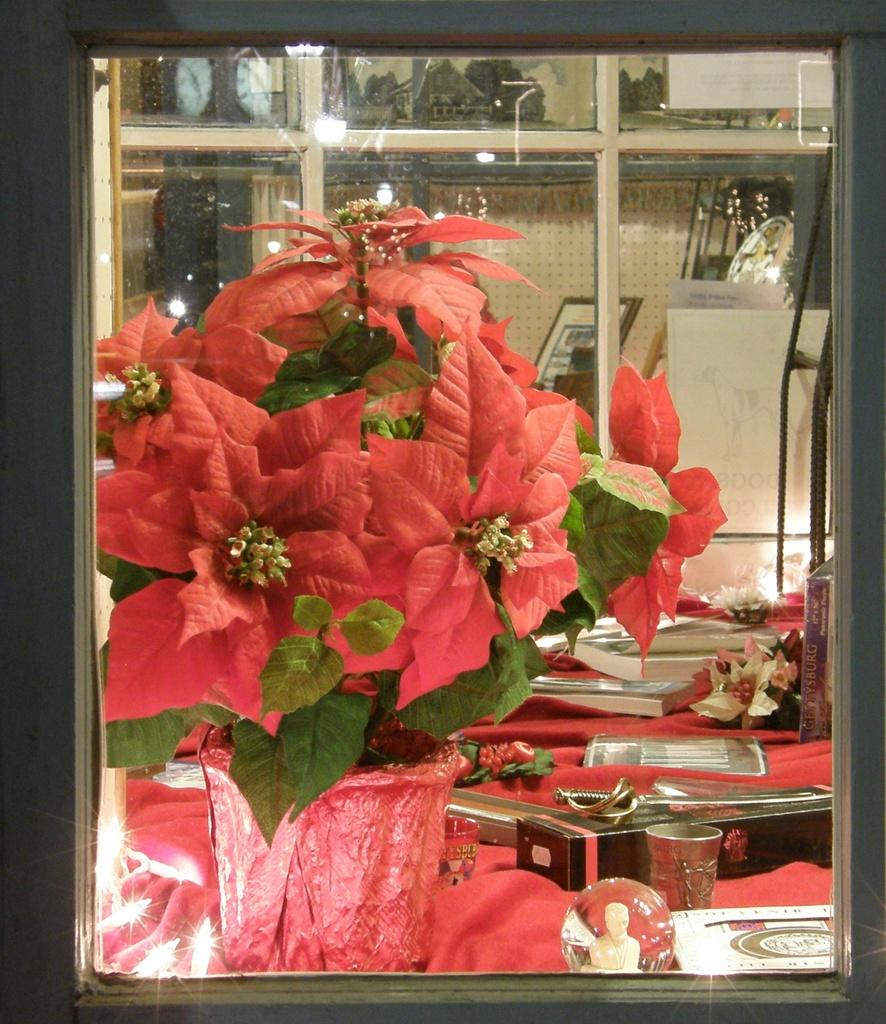What is the main object in the center of the image? There is a flower vase in the center of the image. What can be seen in the background of the image? There are many objects in the background of the image. What type of furniture is present in the image? There is a table in the image with many objects on it. How many cherries are on the table in the image? There is no mention of cherries in the image, so it is impossible to determine how many there are. 